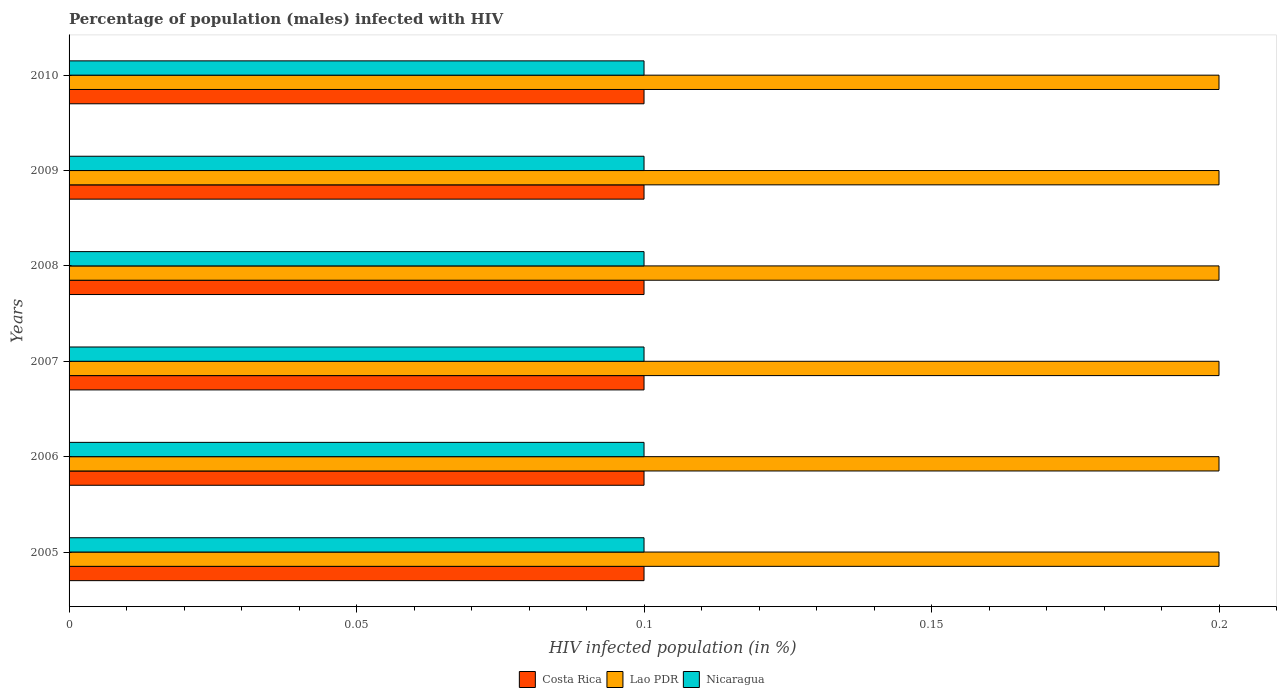How many different coloured bars are there?
Give a very brief answer. 3. How many groups of bars are there?
Make the answer very short. 6. Are the number of bars on each tick of the Y-axis equal?
Provide a succinct answer. Yes. How many bars are there on the 4th tick from the bottom?
Your answer should be compact. 3. In how many cases, is the number of bars for a given year not equal to the number of legend labels?
Your response must be concise. 0. Across all years, what is the maximum percentage of HIV infected male population in Lao PDR?
Offer a terse response. 0.2. Across all years, what is the minimum percentage of HIV infected male population in Nicaragua?
Ensure brevity in your answer.  0.1. In which year was the percentage of HIV infected male population in Nicaragua maximum?
Your answer should be compact. 2005. In which year was the percentage of HIV infected male population in Costa Rica minimum?
Your response must be concise. 2005. What is the difference between the percentage of HIV infected male population in Costa Rica in 2007 and that in 2010?
Keep it short and to the point. 0. What is the average percentage of HIV infected male population in Lao PDR per year?
Keep it short and to the point. 0.2. In the year 2005, what is the difference between the percentage of HIV infected male population in Lao PDR and percentage of HIV infected male population in Costa Rica?
Provide a succinct answer. 0.1. In how many years, is the percentage of HIV infected male population in Nicaragua greater than 0.02 %?
Give a very brief answer. 6. Is the difference between the percentage of HIV infected male population in Lao PDR in 2008 and 2009 greater than the difference between the percentage of HIV infected male population in Costa Rica in 2008 and 2009?
Your answer should be compact. No. What is the difference between the highest and the lowest percentage of HIV infected male population in Lao PDR?
Your response must be concise. 0. Is the sum of the percentage of HIV infected male population in Nicaragua in 2008 and 2009 greater than the maximum percentage of HIV infected male population in Lao PDR across all years?
Offer a very short reply. No. What does the 1st bar from the top in 2008 represents?
Your answer should be compact. Nicaragua. What does the 2nd bar from the bottom in 2008 represents?
Give a very brief answer. Lao PDR. How many bars are there?
Your response must be concise. 18. How many years are there in the graph?
Your answer should be compact. 6. What is the difference between two consecutive major ticks on the X-axis?
Your answer should be compact. 0.05. Does the graph contain any zero values?
Ensure brevity in your answer.  No. Does the graph contain grids?
Your answer should be compact. No. How many legend labels are there?
Your answer should be very brief. 3. What is the title of the graph?
Your answer should be very brief. Percentage of population (males) infected with HIV. What is the label or title of the X-axis?
Your answer should be very brief. HIV infected population (in %). What is the HIV infected population (in %) of Costa Rica in 2006?
Provide a succinct answer. 0.1. What is the HIV infected population (in %) in Lao PDR in 2007?
Your response must be concise. 0.2. What is the HIV infected population (in %) of Costa Rica in 2008?
Offer a very short reply. 0.1. What is the HIV infected population (in %) of Lao PDR in 2008?
Your answer should be very brief. 0.2. What is the HIV infected population (in %) in Nicaragua in 2008?
Provide a succinct answer. 0.1. What is the HIV infected population (in %) of Lao PDR in 2009?
Provide a short and direct response. 0.2. What is the HIV infected population (in %) in Nicaragua in 2009?
Keep it short and to the point. 0.1. What is the HIV infected population (in %) in Costa Rica in 2010?
Make the answer very short. 0.1. Across all years, what is the maximum HIV infected population (in %) of Costa Rica?
Make the answer very short. 0.1. Across all years, what is the maximum HIV infected population (in %) of Nicaragua?
Make the answer very short. 0.1. Across all years, what is the minimum HIV infected population (in %) in Lao PDR?
Provide a short and direct response. 0.2. Across all years, what is the minimum HIV infected population (in %) in Nicaragua?
Your answer should be compact. 0.1. What is the difference between the HIV infected population (in %) in Costa Rica in 2005 and that in 2006?
Offer a terse response. 0. What is the difference between the HIV infected population (in %) of Nicaragua in 2005 and that in 2006?
Provide a short and direct response. 0. What is the difference between the HIV infected population (in %) of Costa Rica in 2005 and that in 2007?
Give a very brief answer. 0. What is the difference between the HIV infected population (in %) of Lao PDR in 2005 and that in 2008?
Ensure brevity in your answer.  0. What is the difference between the HIV infected population (in %) of Nicaragua in 2005 and that in 2008?
Provide a succinct answer. 0. What is the difference between the HIV infected population (in %) in Nicaragua in 2005 and that in 2009?
Your answer should be very brief. 0. What is the difference between the HIV infected population (in %) of Lao PDR in 2005 and that in 2010?
Offer a terse response. 0. What is the difference between the HIV infected population (in %) in Nicaragua in 2005 and that in 2010?
Offer a very short reply. 0. What is the difference between the HIV infected population (in %) of Nicaragua in 2006 and that in 2007?
Provide a succinct answer. 0. What is the difference between the HIV infected population (in %) of Costa Rica in 2006 and that in 2008?
Give a very brief answer. 0. What is the difference between the HIV infected population (in %) of Lao PDR in 2006 and that in 2008?
Make the answer very short. 0. What is the difference between the HIV infected population (in %) in Lao PDR in 2006 and that in 2009?
Provide a short and direct response. 0. What is the difference between the HIV infected population (in %) in Costa Rica in 2006 and that in 2010?
Your answer should be very brief. 0. What is the difference between the HIV infected population (in %) in Costa Rica in 2007 and that in 2008?
Offer a very short reply. 0. What is the difference between the HIV infected population (in %) of Nicaragua in 2007 and that in 2008?
Keep it short and to the point. 0. What is the difference between the HIV infected population (in %) in Costa Rica in 2007 and that in 2009?
Give a very brief answer. 0. What is the difference between the HIV infected population (in %) in Lao PDR in 2007 and that in 2009?
Provide a succinct answer. 0. What is the difference between the HIV infected population (in %) of Nicaragua in 2007 and that in 2009?
Make the answer very short. 0. What is the difference between the HIV infected population (in %) of Lao PDR in 2007 and that in 2010?
Offer a very short reply. 0. What is the difference between the HIV infected population (in %) in Lao PDR in 2008 and that in 2009?
Make the answer very short. 0. What is the difference between the HIV infected population (in %) of Costa Rica in 2008 and that in 2010?
Your response must be concise. 0. What is the difference between the HIV infected population (in %) of Costa Rica in 2009 and that in 2010?
Keep it short and to the point. 0. What is the difference between the HIV infected population (in %) of Lao PDR in 2009 and that in 2010?
Keep it short and to the point. 0. What is the difference between the HIV infected population (in %) in Costa Rica in 2005 and the HIV infected population (in %) in Lao PDR in 2006?
Offer a very short reply. -0.1. What is the difference between the HIV infected population (in %) of Lao PDR in 2005 and the HIV infected population (in %) of Nicaragua in 2006?
Provide a short and direct response. 0.1. What is the difference between the HIV infected population (in %) in Costa Rica in 2005 and the HIV infected population (in %) in Nicaragua in 2007?
Your answer should be compact. 0. What is the difference between the HIV infected population (in %) in Costa Rica in 2005 and the HIV infected population (in %) in Nicaragua in 2008?
Your answer should be compact. 0. What is the difference between the HIV infected population (in %) in Costa Rica in 2005 and the HIV infected population (in %) in Lao PDR in 2009?
Provide a succinct answer. -0.1. What is the difference between the HIV infected population (in %) in Costa Rica in 2005 and the HIV infected population (in %) in Nicaragua in 2009?
Your answer should be very brief. 0. What is the difference between the HIV infected population (in %) of Lao PDR in 2005 and the HIV infected population (in %) of Nicaragua in 2009?
Give a very brief answer. 0.1. What is the difference between the HIV infected population (in %) of Lao PDR in 2005 and the HIV infected population (in %) of Nicaragua in 2010?
Your answer should be compact. 0.1. What is the difference between the HIV infected population (in %) of Costa Rica in 2006 and the HIV infected population (in %) of Lao PDR in 2007?
Provide a short and direct response. -0.1. What is the difference between the HIV infected population (in %) in Lao PDR in 2006 and the HIV infected population (in %) in Nicaragua in 2007?
Give a very brief answer. 0.1. What is the difference between the HIV infected population (in %) of Costa Rica in 2006 and the HIV infected population (in %) of Nicaragua in 2008?
Offer a very short reply. 0. What is the difference between the HIV infected population (in %) in Costa Rica in 2006 and the HIV infected population (in %) in Nicaragua in 2009?
Provide a short and direct response. 0. What is the difference between the HIV infected population (in %) of Costa Rica in 2006 and the HIV infected population (in %) of Lao PDR in 2010?
Keep it short and to the point. -0.1. What is the difference between the HIV infected population (in %) of Costa Rica in 2006 and the HIV infected population (in %) of Nicaragua in 2010?
Your answer should be compact. 0. What is the difference between the HIV infected population (in %) of Lao PDR in 2006 and the HIV infected population (in %) of Nicaragua in 2010?
Ensure brevity in your answer.  0.1. What is the difference between the HIV infected population (in %) of Costa Rica in 2007 and the HIV infected population (in %) of Lao PDR in 2009?
Give a very brief answer. -0.1. What is the difference between the HIV infected population (in %) of Costa Rica in 2007 and the HIV infected population (in %) of Nicaragua in 2010?
Offer a terse response. 0. What is the difference between the HIV infected population (in %) in Lao PDR in 2007 and the HIV infected population (in %) in Nicaragua in 2010?
Make the answer very short. 0.1. What is the difference between the HIV infected population (in %) in Costa Rica in 2008 and the HIV infected population (in %) in Lao PDR in 2009?
Provide a succinct answer. -0.1. What is the difference between the HIV infected population (in %) of Costa Rica in 2008 and the HIV infected population (in %) of Nicaragua in 2010?
Make the answer very short. 0. What is the difference between the HIV infected population (in %) in Costa Rica in 2009 and the HIV infected population (in %) in Nicaragua in 2010?
Provide a short and direct response. 0. What is the average HIV infected population (in %) of Costa Rica per year?
Keep it short and to the point. 0.1. What is the average HIV infected population (in %) in Nicaragua per year?
Keep it short and to the point. 0.1. In the year 2005, what is the difference between the HIV infected population (in %) in Costa Rica and HIV infected population (in %) in Lao PDR?
Your answer should be compact. -0.1. In the year 2006, what is the difference between the HIV infected population (in %) of Costa Rica and HIV infected population (in %) of Lao PDR?
Keep it short and to the point. -0.1. In the year 2007, what is the difference between the HIV infected population (in %) of Costa Rica and HIV infected population (in %) of Lao PDR?
Provide a succinct answer. -0.1. In the year 2007, what is the difference between the HIV infected population (in %) in Lao PDR and HIV infected population (in %) in Nicaragua?
Offer a very short reply. 0.1. In the year 2008, what is the difference between the HIV infected population (in %) of Costa Rica and HIV infected population (in %) of Nicaragua?
Ensure brevity in your answer.  0. In the year 2008, what is the difference between the HIV infected population (in %) of Lao PDR and HIV infected population (in %) of Nicaragua?
Keep it short and to the point. 0.1. In the year 2009, what is the difference between the HIV infected population (in %) of Lao PDR and HIV infected population (in %) of Nicaragua?
Make the answer very short. 0.1. What is the ratio of the HIV infected population (in %) of Lao PDR in 2005 to that in 2007?
Offer a terse response. 1. What is the ratio of the HIV infected population (in %) in Nicaragua in 2005 to that in 2007?
Your answer should be compact. 1. What is the ratio of the HIV infected population (in %) in Lao PDR in 2005 to that in 2008?
Offer a very short reply. 1. What is the ratio of the HIV infected population (in %) of Nicaragua in 2005 to that in 2009?
Ensure brevity in your answer.  1. What is the ratio of the HIV infected population (in %) in Costa Rica in 2005 to that in 2010?
Ensure brevity in your answer.  1. What is the ratio of the HIV infected population (in %) of Lao PDR in 2005 to that in 2010?
Give a very brief answer. 1. What is the ratio of the HIV infected population (in %) in Costa Rica in 2006 to that in 2007?
Offer a very short reply. 1. What is the ratio of the HIV infected population (in %) of Lao PDR in 2006 to that in 2007?
Provide a short and direct response. 1. What is the ratio of the HIV infected population (in %) of Nicaragua in 2006 to that in 2008?
Give a very brief answer. 1. What is the ratio of the HIV infected population (in %) in Nicaragua in 2006 to that in 2009?
Make the answer very short. 1. What is the ratio of the HIV infected population (in %) of Lao PDR in 2006 to that in 2010?
Your answer should be compact. 1. What is the ratio of the HIV infected population (in %) in Nicaragua in 2006 to that in 2010?
Ensure brevity in your answer.  1. What is the ratio of the HIV infected population (in %) of Lao PDR in 2007 to that in 2008?
Offer a very short reply. 1. What is the ratio of the HIV infected population (in %) of Nicaragua in 2007 to that in 2008?
Ensure brevity in your answer.  1. What is the ratio of the HIV infected population (in %) in Costa Rica in 2007 to that in 2009?
Keep it short and to the point. 1. What is the ratio of the HIV infected population (in %) in Lao PDR in 2007 to that in 2009?
Provide a short and direct response. 1. What is the ratio of the HIV infected population (in %) in Costa Rica in 2007 to that in 2010?
Your answer should be very brief. 1. What is the ratio of the HIV infected population (in %) of Nicaragua in 2007 to that in 2010?
Your answer should be compact. 1. What is the ratio of the HIV infected population (in %) of Costa Rica in 2008 to that in 2009?
Provide a succinct answer. 1. What is the ratio of the HIV infected population (in %) of Lao PDR in 2008 to that in 2009?
Give a very brief answer. 1. What is the ratio of the HIV infected population (in %) in Nicaragua in 2008 to that in 2009?
Ensure brevity in your answer.  1. What is the ratio of the HIV infected population (in %) of Nicaragua in 2008 to that in 2010?
Keep it short and to the point. 1. What is the ratio of the HIV infected population (in %) of Costa Rica in 2009 to that in 2010?
Offer a terse response. 1. What is the ratio of the HIV infected population (in %) of Lao PDR in 2009 to that in 2010?
Ensure brevity in your answer.  1. What is the ratio of the HIV infected population (in %) of Nicaragua in 2009 to that in 2010?
Ensure brevity in your answer.  1. What is the difference between the highest and the second highest HIV infected population (in %) in Costa Rica?
Your answer should be very brief. 0. 